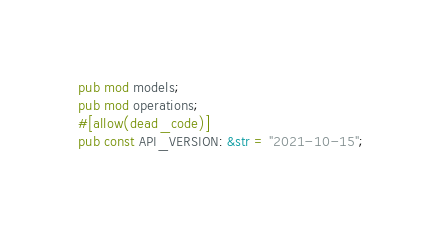<code> <loc_0><loc_0><loc_500><loc_500><_Rust_>pub mod models;
pub mod operations;
#[allow(dead_code)]
pub const API_VERSION: &str = "2021-10-15";
</code> 